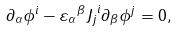<formula> <loc_0><loc_0><loc_500><loc_500>\partial _ { \alpha } \phi ^ { i } - { \varepsilon _ { \alpha } } ^ { \beta } { J _ { j } } ^ { i } \partial _ { \beta } \phi ^ { j } = 0 ,</formula> 